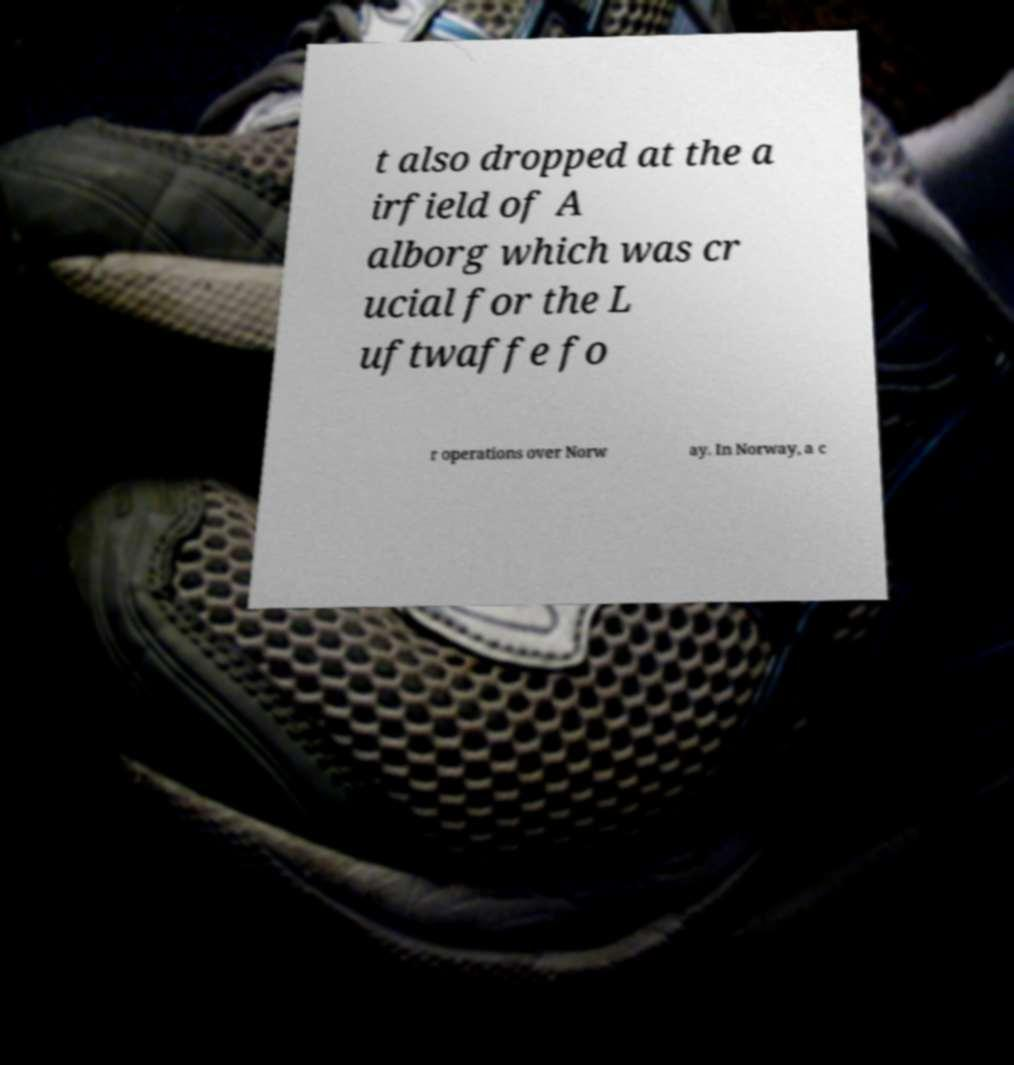What messages or text are displayed in this image? I need them in a readable, typed format. t also dropped at the a irfield of A alborg which was cr ucial for the L uftwaffe fo r operations over Norw ay. In Norway, a c 